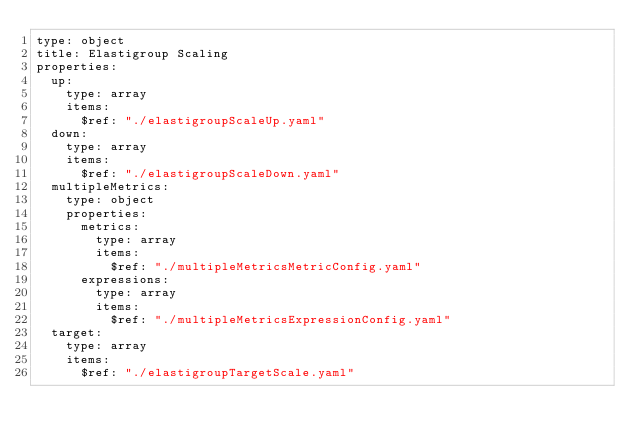Convert code to text. <code><loc_0><loc_0><loc_500><loc_500><_YAML_>type: object
title: Elastigroup Scaling
properties:
  up:
    type: array
    items:
      $ref: "./elastigroupScaleUp.yaml"
  down:
    type: array
    items:
      $ref: "./elastigroupScaleDown.yaml"
  multipleMetrics:
    type: object
    properties:
      metrics:
        type: array
        items:
          $ref: "./multipleMetricsMetricConfig.yaml"
      expressions:
        type: array
        items:
          $ref: "./multipleMetricsExpressionConfig.yaml"
  target:
    type: array
    items:
      $ref: "./elastigroupTargetScale.yaml"
</code> 